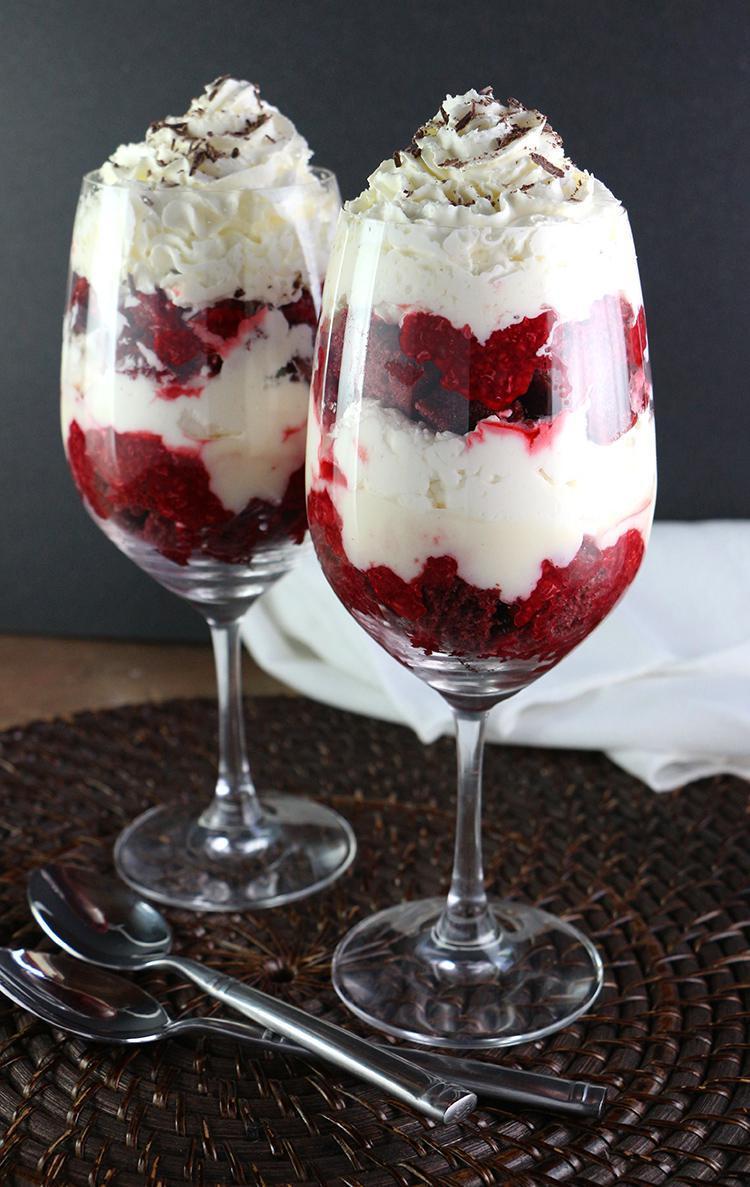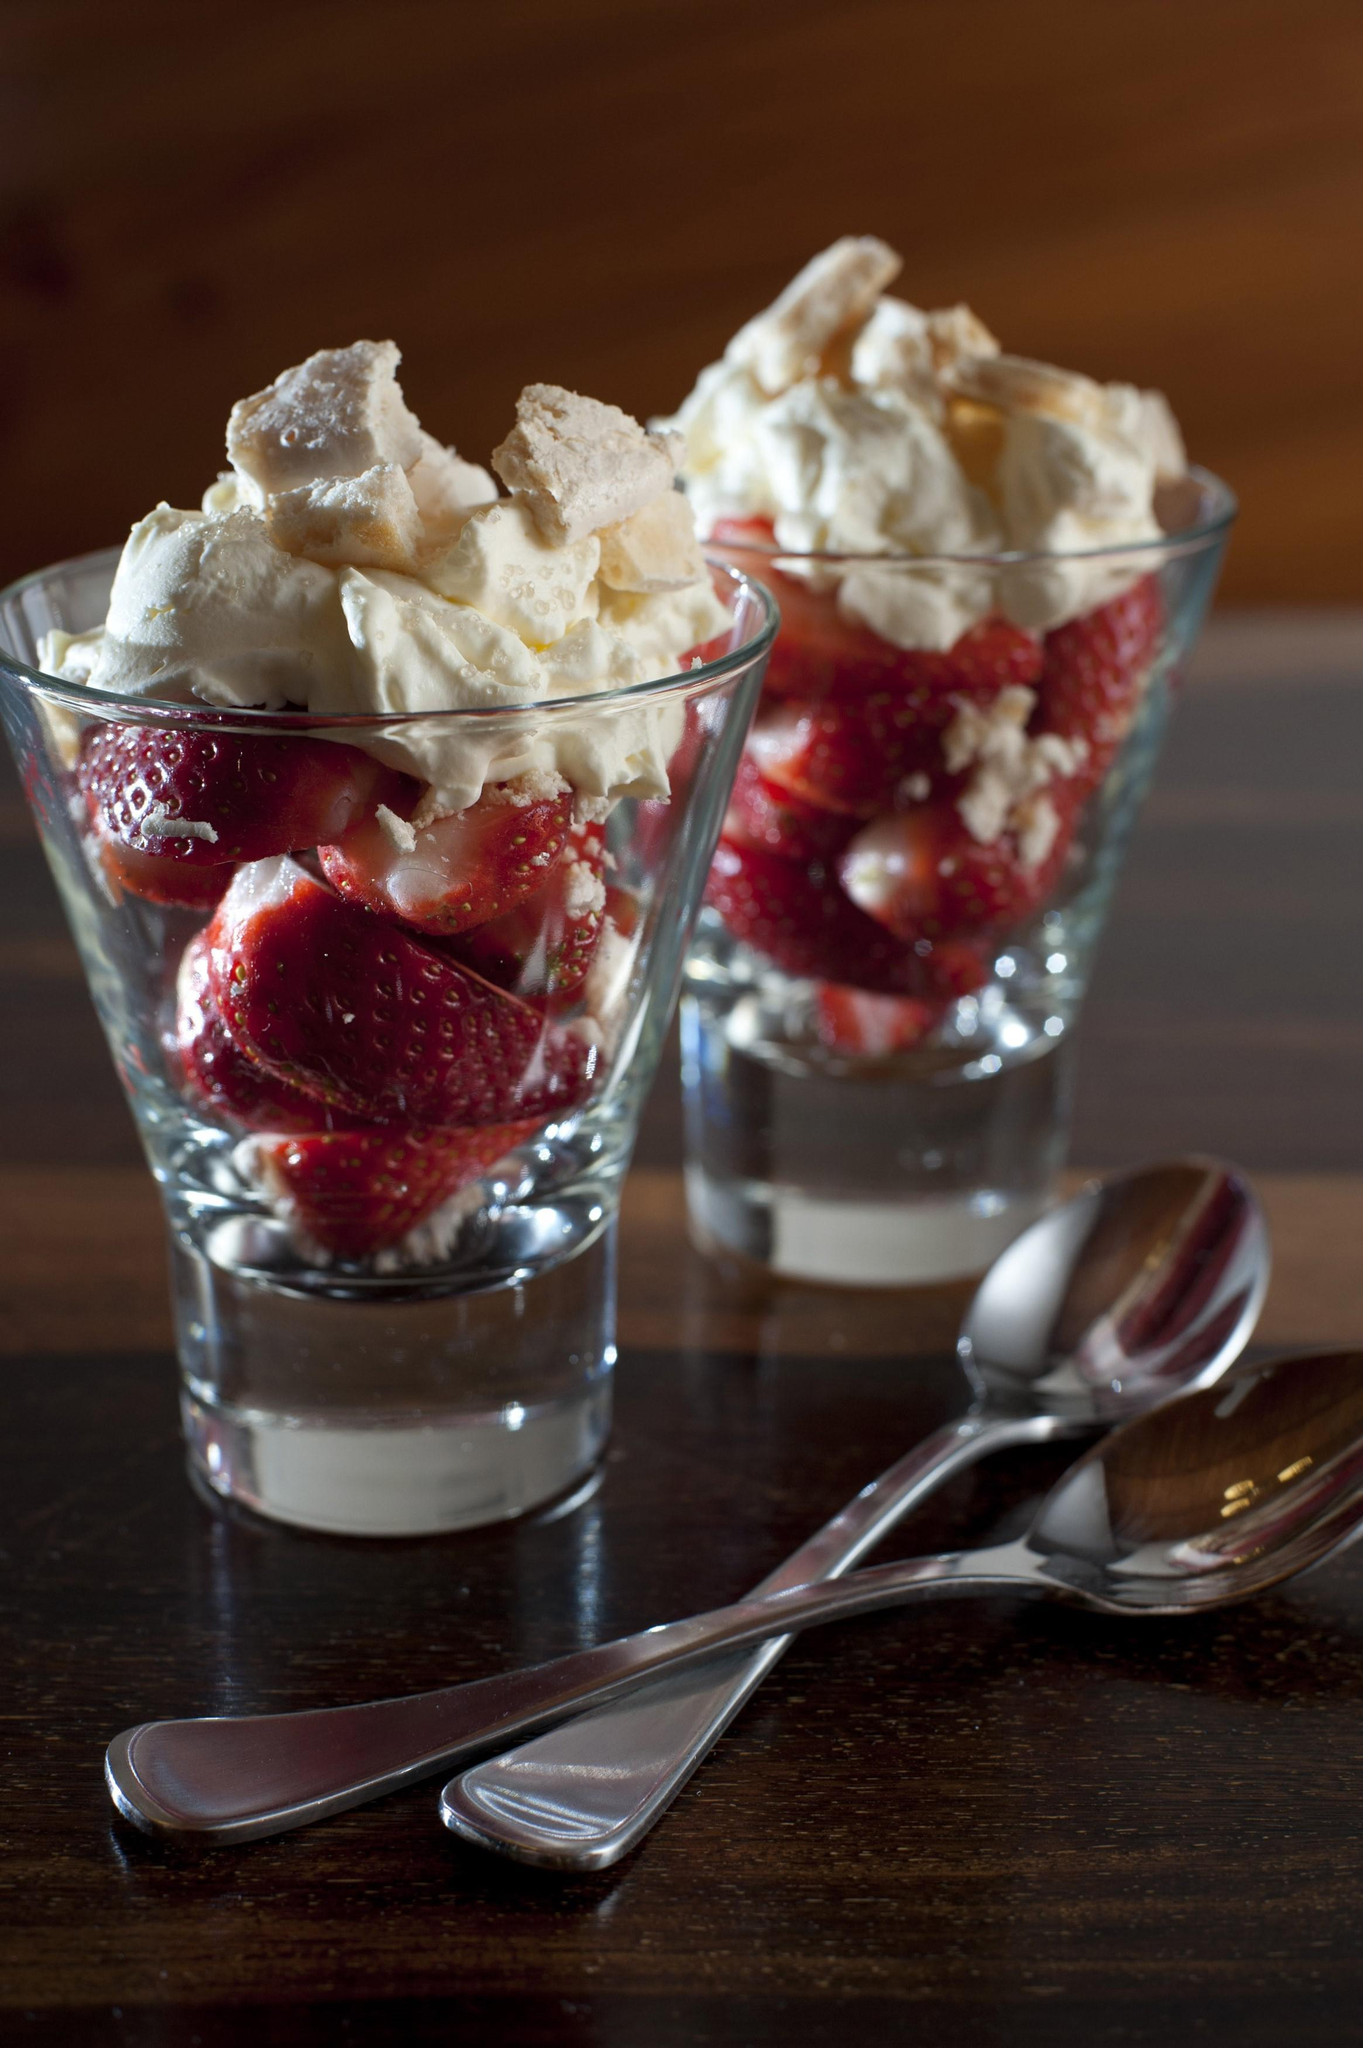The first image is the image on the left, the second image is the image on the right. Analyze the images presented: Is the assertion "There are exactly four layered desserts in cups." valid? Answer yes or no. Yes. The first image is the image on the left, the second image is the image on the right. Analyze the images presented: Is the assertion "An image shows a pair of martini-style glasses containing desserts that include a red layer surrounded by white cream, and a bottom chocolate layer." valid? Answer yes or no. No. 